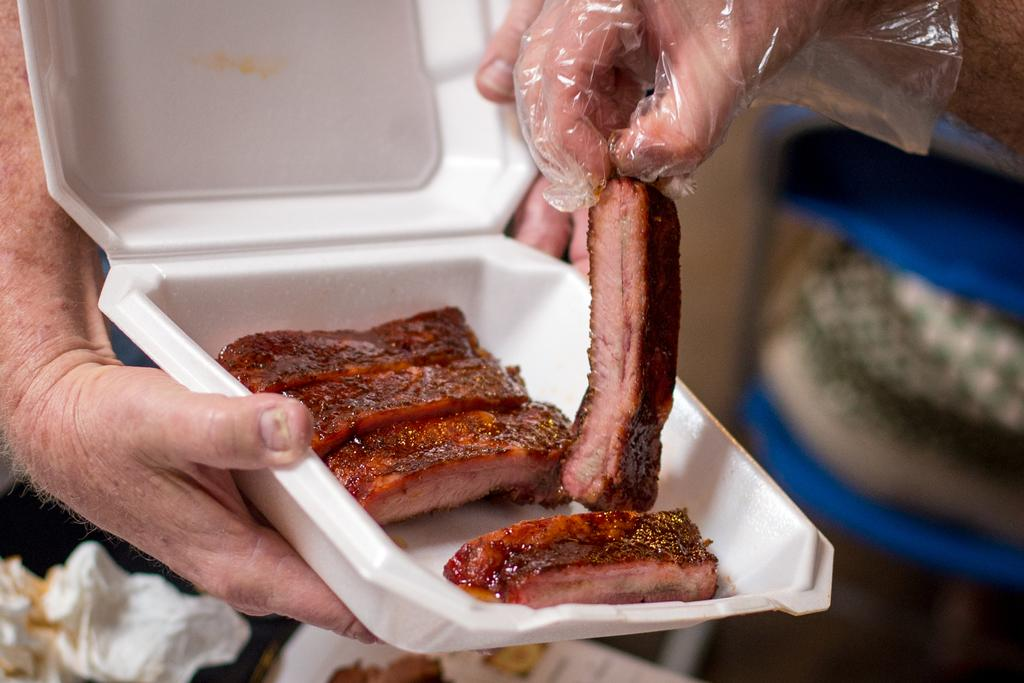What is the main subject of the image? There is a person in the image. What is the person holding in the image? The person is holding a box with his hands. What is inside the box? There is a food item in the box. Can you describe the hand holding a food item in the image? There is a hand holding a food item in the top right of the image. What is the background of the image like? The background of the image is blurred. What type of wire is being used to cook the meal in the image? There is no wire or meal present in the image. How many matches are visible in the image? There are no matches visible in the image. 